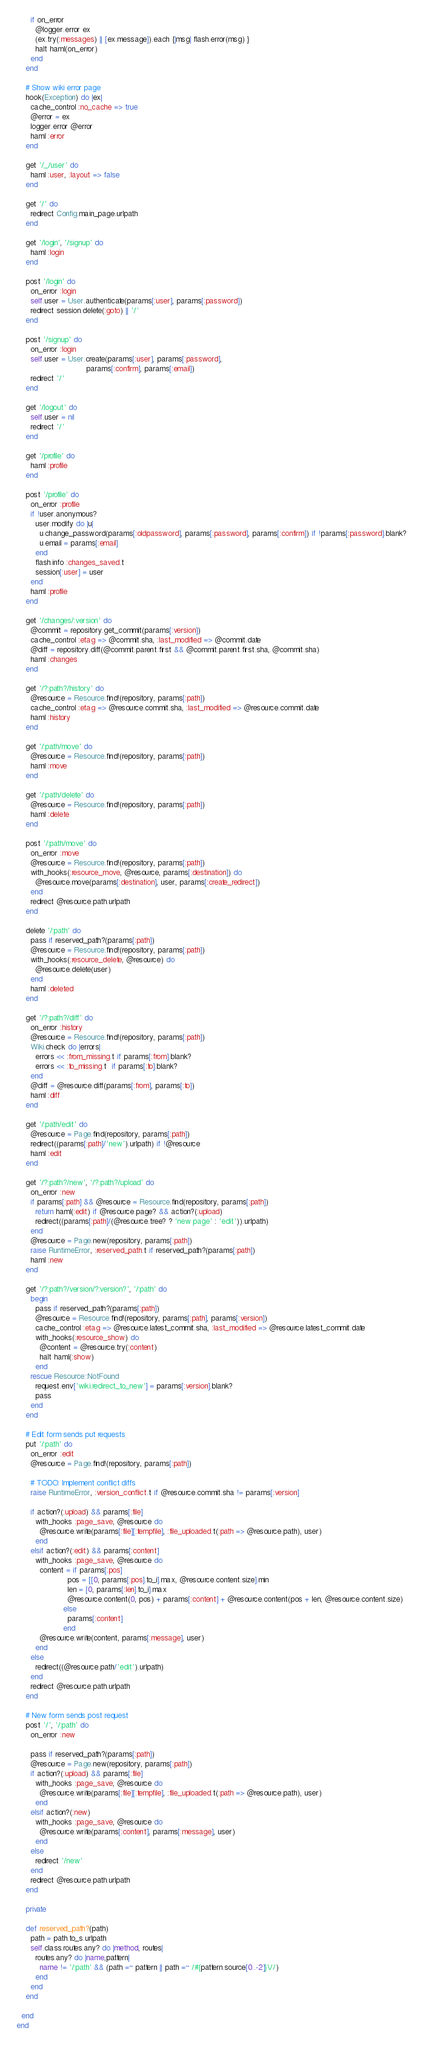<code> <loc_0><loc_0><loc_500><loc_500><_Ruby_>      if on_error
        @logger.error ex
        (ex.try(:messages) || [ex.message]).each {|msg| flash.error(msg) }
        halt haml(on_error)
      end
    end

    # Show wiki error page
    hook(Exception) do |ex|
      cache_control :no_cache => true
      @error = ex
      logger.error @error
      haml :error
    end

    get '/_/user' do
      haml :user, :layout => false
    end

    get '/' do
      redirect Config.main_page.urlpath
    end

    get '/login', '/signup' do
      haml :login
    end

    post '/login' do
      on_error :login
      self.user = User.authenticate(params[:user], params[:password])
      redirect session.delete(:goto) || '/'
    end

    post '/signup' do
      on_error :login
      self.user = User.create(params[:user], params[:password],
                              params[:confirm], params[:email])
      redirect '/'
    end

    get '/logout' do
      self.user = nil
      redirect '/'
    end

    get '/profile' do
      haml :profile
    end

    post '/profile' do
      on_error :profile
      if !user.anonymous?
        user.modify do |u|
          u.change_password(params[:oldpassword], params[:password], params[:confirm]) if !params[:password].blank?
          u.email = params[:email]
        end
        flash.info :changes_saved.t
        session[:user] = user
      end
      haml :profile
    end

    get '/changes/:version' do
      @commit = repository.get_commit(params[:version])
      cache_control :etag => @commit.sha, :last_modified => @commit.date
      @diff = repository.diff(@commit.parent.first && @commit.parent.first.sha, @commit.sha)
      haml :changes
    end

    get '/?:path?/history' do
      @resource = Resource.find!(repository, params[:path])
      cache_control :etag => @resource.commit.sha, :last_modified => @resource.commit.date
      haml :history
    end

    get '/:path/move' do
      @resource = Resource.find!(repository, params[:path])
      haml :move
    end

    get '/:path/delete' do
      @resource = Resource.find!(repository, params[:path])
      haml :delete
    end

    post '/:path/move' do
      on_error :move
      @resource = Resource.find!(repository, params[:path])
      with_hooks(:resource_move, @resource, params[:destination]) do
        @resource.move(params[:destination], user, params[:create_redirect])
      end
      redirect @resource.path.urlpath
    end

    delete '/:path' do
      pass if reserved_path?(params[:path])
      @resource = Resource.find!(repository, params[:path])
      with_hooks(:resource_delete, @resource) do
        @resource.delete(user)
      end
      haml :deleted
    end

    get '/?:path?/diff' do
      on_error :history
      @resource = Resource.find!(repository, params[:path])
      Wiki.check do |errors|
        errors << :from_missing.t if params[:from].blank?
        errors << :to_missing.t  if params[:to].blank?
      end
      @diff = @resource.diff(params[:from], params[:to])
      haml :diff
    end

    get '/:path/edit' do
      @resource = Page.find(repository, params[:path])
      redirect((params[:path]/'new').urlpath) if !@resource
      haml :edit
    end

    get '/?:path?/new', '/?:path?/upload' do
      on_error :new
      if params[:path] && @resource = Resource.find(repository, params[:path])
        return haml(:edit) if @resource.page? && action?(:upload)
        redirect((params[:path]/(@resource.tree? ? 'new page' : 'edit')).urlpath)
      end
      @resource = Page.new(repository, params[:path])
      raise RuntimeError, :reserved_path.t if reserved_path?(params[:path])
      haml :new
    end

    get '/?:path?/version/?:version?', '/:path' do
      begin
        pass if reserved_path?(params[:path])
        @resource = Resource.find!(repository, params[:path], params[:version])
        cache_control :etag => @resource.latest_commit.sha, :last_modified => @resource.latest_commit.date
        with_hooks(:resource_show) do
          @content = @resource.try(:content)
          halt haml(:show)
        end
      rescue Resource::NotFound
        request.env['wiki.redirect_to_new'] = params[:version].blank?
        pass
      end
    end

    # Edit form sends put requests
    put '/:path' do
      on_error :edit
      @resource = Page.find!(repository, params[:path])

      # TODO: Implement conflict diffs
      raise RuntimeError, :version_conflict.t if @resource.commit.sha != params[:version]

      if action?(:upload) && params[:file]
        with_hooks :page_save, @resource do
          @resource.write(params[:file][:tempfile], :file_uploaded.t(:path => @resource.path), user)
        end
      elsif action?(:edit) && params[:content]
        with_hooks :page_save, @resource do
          content = if params[:pos]
                      pos = [[0, params[:pos].to_i].max, @resource.content.size].min
                      len = [0, params[:len].to_i].max
                      @resource.content(0, pos) + params[:content] + @resource.content(pos + len, @resource.content.size)
                    else
                      params[:content]
                    end
          @resource.write(content, params[:message], user)
        end
      else
        redirect((@resource.path/'edit').urlpath)
      end
      redirect @resource.path.urlpath
    end

    # New form sends post request
    post '/', '/:path' do
      on_error :new

      pass if reserved_path?(params[:path])
      @resource = Page.new(repository, params[:path])
      if action?(:upload) && params[:file]
        with_hooks :page_save, @resource do
          @resource.write(params[:file][:tempfile], :file_uploaded.t(:path => @resource.path), user)
        end
      elsif action?(:new)
        with_hooks :page_save, @resource do
          @resource.write(params[:content], params[:message], user)
        end
      else
        redirect '/new'
      end
      redirect @resource.path.urlpath
    end

    private

    def reserved_path?(path)
      path = path.to_s.urlpath
      self.class.routes.any? do |method, routes|
        routes.any? do |name,pattern|
          name != '/:path' && (path =~ pattern || path =~ /#{pattern.source[0..-2]}\//)
        end
      end
    end

  end
end
</code> 